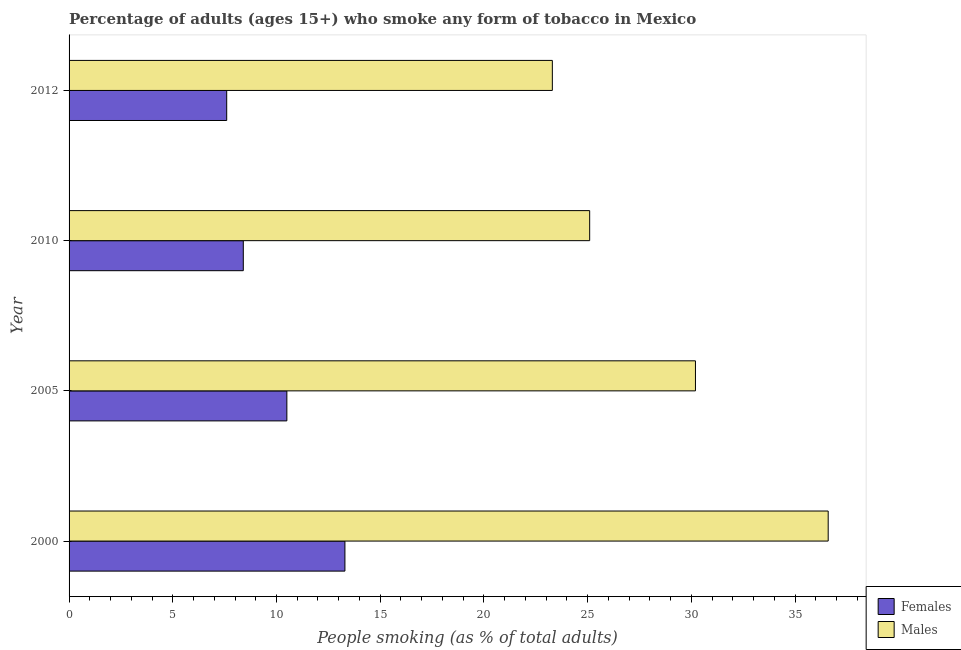Are the number of bars per tick equal to the number of legend labels?
Make the answer very short. Yes. How many bars are there on the 1st tick from the top?
Your answer should be compact. 2. What is the percentage of males who smoke in 2010?
Ensure brevity in your answer.  25.1. Across all years, what is the maximum percentage of males who smoke?
Offer a very short reply. 36.6. Across all years, what is the minimum percentage of males who smoke?
Offer a terse response. 23.3. In which year was the percentage of females who smoke maximum?
Your response must be concise. 2000. What is the total percentage of males who smoke in the graph?
Provide a succinct answer. 115.2. What is the difference between the percentage of males who smoke in 2000 and the percentage of females who smoke in 2010?
Provide a succinct answer. 28.2. What is the average percentage of females who smoke per year?
Offer a very short reply. 9.95. In the year 2005, what is the difference between the percentage of females who smoke and percentage of males who smoke?
Make the answer very short. -19.7. What is the ratio of the percentage of males who smoke in 2005 to that in 2012?
Give a very brief answer. 1.3. Is the difference between the percentage of females who smoke in 2005 and 2010 greater than the difference between the percentage of males who smoke in 2005 and 2010?
Offer a terse response. No. What is the difference between the highest and the second highest percentage of males who smoke?
Your response must be concise. 6.4. In how many years, is the percentage of females who smoke greater than the average percentage of females who smoke taken over all years?
Make the answer very short. 2. What does the 2nd bar from the top in 2005 represents?
Offer a very short reply. Females. What does the 2nd bar from the bottom in 2010 represents?
Your answer should be very brief. Males. How many years are there in the graph?
Your answer should be very brief. 4. What is the difference between two consecutive major ticks on the X-axis?
Offer a terse response. 5. Are the values on the major ticks of X-axis written in scientific E-notation?
Ensure brevity in your answer.  No. How are the legend labels stacked?
Offer a very short reply. Vertical. What is the title of the graph?
Your answer should be very brief. Percentage of adults (ages 15+) who smoke any form of tobacco in Mexico. What is the label or title of the X-axis?
Keep it short and to the point. People smoking (as % of total adults). What is the People smoking (as % of total adults) in Males in 2000?
Offer a very short reply. 36.6. What is the People smoking (as % of total adults) in Females in 2005?
Ensure brevity in your answer.  10.5. What is the People smoking (as % of total adults) of Males in 2005?
Your answer should be compact. 30.2. What is the People smoking (as % of total adults) of Females in 2010?
Your answer should be compact. 8.4. What is the People smoking (as % of total adults) of Males in 2010?
Provide a short and direct response. 25.1. What is the People smoking (as % of total adults) in Females in 2012?
Your answer should be compact. 7.6. What is the People smoking (as % of total adults) in Males in 2012?
Offer a very short reply. 23.3. Across all years, what is the maximum People smoking (as % of total adults) in Males?
Ensure brevity in your answer.  36.6. Across all years, what is the minimum People smoking (as % of total adults) in Males?
Ensure brevity in your answer.  23.3. What is the total People smoking (as % of total adults) in Females in the graph?
Provide a succinct answer. 39.8. What is the total People smoking (as % of total adults) of Males in the graph?
Give a very brief answer. 115.2. What is the difference between the People smoking (as % of total adults) in Females in 2000 and that in 2010?
Offer a very short reply. 4.9. What is the difference between the People smoking (as % of total adults) in Males in 2000 and that in 2012?
Make the answer very short. 13.3. What is the difference between the People smoking (as % of total adults) of Females in 2005 and that in 2010?
Provide a short and direct response. 2.1. What is the difference between the People smoking (as % of total adults) in Females in 2005 and that in 2012?
Your answer should be very brief. 2.9. What is the difference between the People smoking (as % of total adults) in Males in 2005 and that in 2012?
Provide a succinct answer. 6.9. What is the difference between the People smoking (as % of total adults) in Females in 2010 and that in 2012?
Keep it short and to the point. 0.8. What is the difference between the People smoking (as % of total adults) of Females in 2000 and the People smoking (as % of total adults) of Males in 2005?
Keep it short and to the point. -16.9. What is the difference between the People smoking (as % of total adults) of Females in 2005 and the People smoking (as % of total adults) of Males in 2010?
Keep it short and to the point. -14.6. What is the difference between the People smoking (as % of total adults) of Females in 2010 and the People smoking (as % of total adults) of Males in 2012?
Your answer should be very brief. -14.9. What is the average People smoking (as % of total adults) of Females per year?
Keep it short and to the point. 9.95. What is the average People smoking (as % of total adults) in Males per year?
Make the answer very short. 28.8. In the year 2000, what is the difference between the People smoking (as % of total adults) in Females and People smoking (as % of total adults) in Males?
Give a very brief answer. -23.3. In the year 2005, what is the difference between the People smoking (as % of total adults) of Females and People smoking (as % of total adults) of Males?
Offer a terse response. -19.7. In the year 2010, what is the difference between the People smoking (as % of total adults) of Females and People smoking (as % of total adults) of Males?
Ensure brevity in your answer.  -16.7. In the year 2012, what is the difference between the People smoking (as % of total adults) in Females and People smoking (as % of total adults) in Males?
Make the answer very short. -15.7. What is the ratio of the People smoking (as % of total adults) of Females in 2000 to that in 2005?
Offer a very short reply. 1.27. What is the ratio of the People smoking (as % of total adults) in Males in 2000 to that in 2005?
Your answer should be compact. 1.21. What is the ratio of the People smoking (as % of total adults) in Females in 2000 to that in 2010?
Provide a succinct answer. 1.58. What is the ratio of the People smoking (as % of total adults) of Males in 2000 to that in 2010?
Your response must be concise. 1.46. What is the ratio of the People smoking (as % of total adults) in Males in 2000 to that in 2012?
Offer a terse response. 1.57. What is the ratio of the People smoking (as % of total adults) of Females in 2005 to that in 2010?
Offer a terse response. 1.25. What is the ratio of the People smoking (as % of total adults) in Males in 2005 to that in 2010?
Offer a terse response. 1.2. What is the ratio of the People smoking (as % of total adults) in Females in 2005 to that in 2012?
Provide a short and direct response. 1.38. What is the ratio of the People smoking (as % of total adults) in Males in 2005 to that in 2012?
Offer a terse response. 1.3. What is the ratio of the People smoking (as % of total adults) of Females in 2010 to that in 2012?
Offer a terse response. 1.11. What is the ratio of the People smoking (as % of total adults) in Males in 2010 to that in 2012?
Keep it short and to the point. 1.08. What is the difference between the highest and the second highest People smoking (as % of total adults) of Males?
Provide a short and direct response. 6.4. 